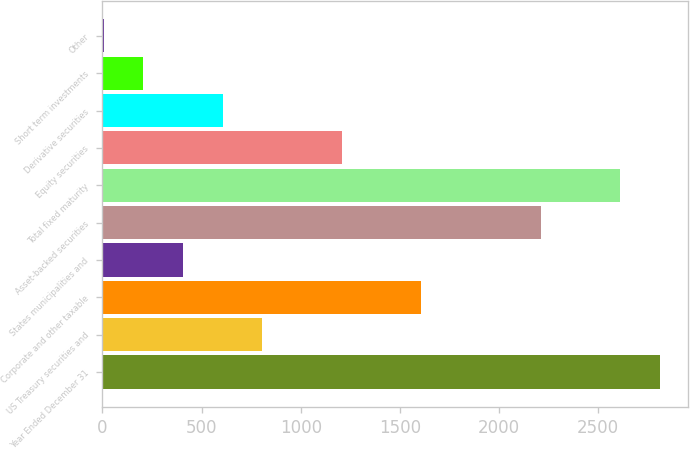Convert chart to OTSL. <chart><loc_0><loc_0><loc_500><loc_500><bar_chart><fcel>Year Ended December 31<fcel>US Treasury securities and<fcel>Corporate and other taxable<fcel>States municipalities and<fcel>Asset-backed securities<fcel>Total fixed maturity<fcel>Equity securities<fcel>Derivative securities<fcel>Short term investments<fcel>Other<nl><fcel>2810.2<fcel>807.2<fcel>1608.4<fcel>406.6<fcel>2209.3<fcel>2609.9<fcel>1207.8<fcel>606.9<fcel>206.3<fcel>6<nl></chart> 